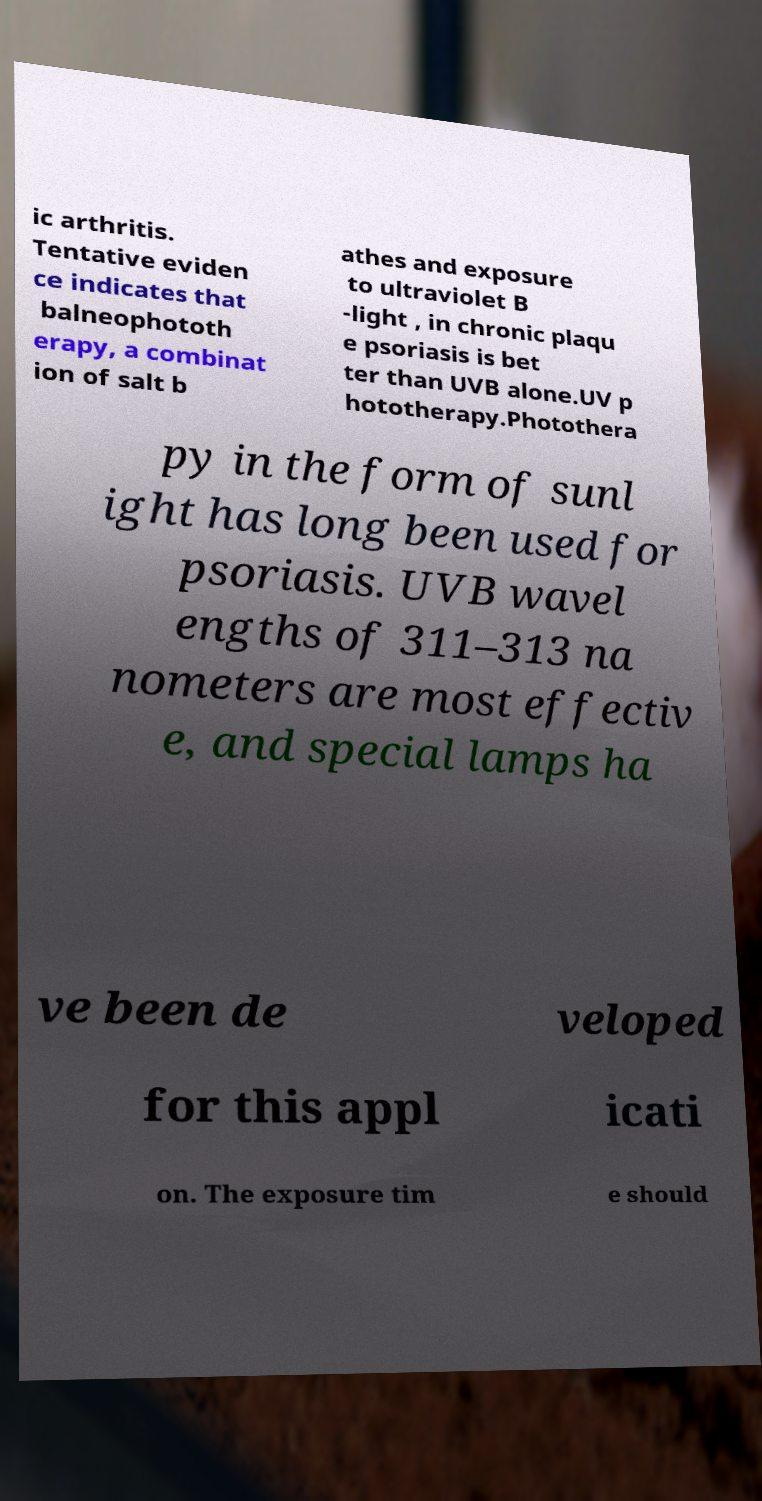What messages or text are displayed in this image? I need them in a readable, typed format. ic arthritis. Tentative eviden ce indicates that balneophototh erapy, a combinat ion of salt b athes and exposure to ultraviolet B -light , in chronic plaqu e psoriasis is bet ter than UVB alone.UV p hototherapy.Photothera py in the form of sunl ight has long been used for psoriasis. UVB wavel engths of 311–313 na nometers are most effectiv e, and special lamps ha ve been de veloped for this appl icati on. The exposure tim e should 